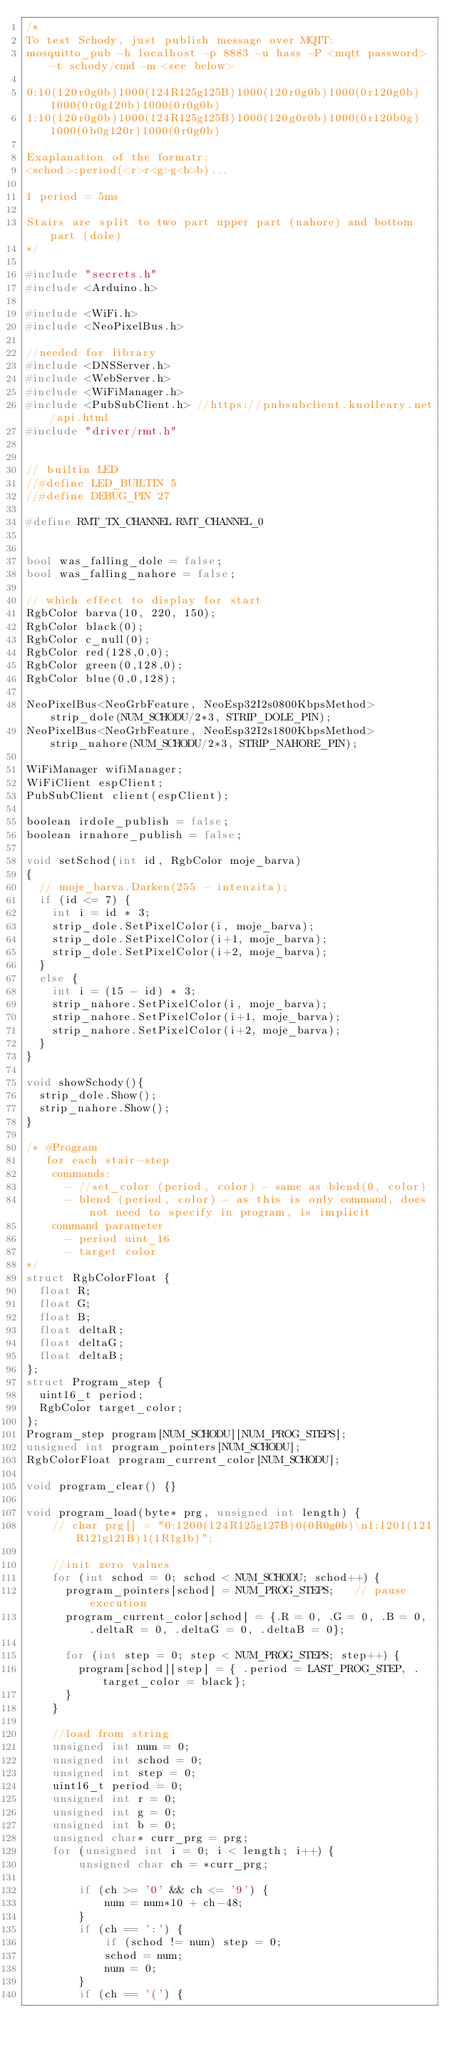<code> <loc_0><loc_0><loc_500><loc_500><_C++_>/*
To test Schody, just publish message over MQTT:
mosquitto_pub -h localhost -p 8883 -u hass -P <mqtt password> -t schody/cmd -m <see below>

0:10(120r0g0b)1000(124R125g125B)1000(120r0g0b)1000(0r120g0b)1000(0r0g120b)1000(0r0g0b)
1:10(120r0g0b)1000(124R125g125B)1000(120g0r0b)1000(0r120b0g)1000(0b0g120r)1000(0r0g0b)

Exaplanation of the formatr:
<schod>:period(<r>r<g>g<b>b)...

1 period = 5ms

Stairs are split to two part upper part (nahore) and bottom part (dole) 
*/

#include "secrets.h"
#include <Arduino.h>

#include <WiFi.h>
#include <NeoPixelBus.h>

//needed for library
#include <DNSServer.h>
#include <WebServer.h>
#include <WiFiManager.h>
#include <PubSubClient.h> //https://pubsubclient.knolleary.net/api.html
#include "driver/rmt.h"


// builtin LED
//#define LED_BUILTIN 5
//#define DEBUG_PIN 27

#define RMT_TX_CHANNEL RMT_CHANNEL_0


bool was_falling_dole = false;
bool was_falling_nahore = false;

// which effect to display for start
RgbColor barva(10, 220, 150);
RgbColor black(0);
RgbColor c_null(0);
RgbColor red(128,0,0);
RgbColor green(0,128,0);
RgbColor blue(0,0,128);

NeoPixelBus<NeoGrbFeature, NeoEsp32I2s0800KbpsMethod> strip_dole(NUM_SCHODU/2*3, STRIP_DOLE_PIN);
NeoPixelBus<NeoGrbFeature, NeoEsp32I2s1800KbpsMethod> strip_nahore(NUM_SCHODU/2*3, STRIP_NAHORE_PIN);

WiFiManager wifiManager;
WiFiClient espClient;
PubSubClient client(espClient);

boolean irdole_publish = false;
boolean irnahore_publish = false;

void setSchod(int id, RgbColor moje_barva)
{
  // moje_barva.Darken(255 - intenzita);
  if (id <= 7) {
    int i = id * 3;
    strip_dole.SetPixelColor(i, moje_barva);
    strip_dole.SetPixelColor(i+1, moje_barva);
    strip_dole.SetPixelColor(i+2, moje_barva);
  }
  else {
    int i = (15 - id) * 3;
    strip_nahore.SetPixelColor(i, moje_barva);
    strip_nahore.SetPixelColor(i+1, moje_barva);
    strip_nahore.SetPixelColor(i+2, moje_barva);
  }
}

void showSchody(){
  strip_dole.Show();
  strip_nahore.Show();
}

/* #Program
   for each stair-step
    commands:
      - //set_color (period, color) - same as blend(0, color)
      - blend (period, color) - as this is only command, does not need to specify in program, is implicit
    command parameter
      - period uint_16
      - target color
*/
struct RgbColorFloat {
  float R;
  float G;
  float B;
  float deltaR;
  float deltaG;
  float deltaB;
};
struct Program_step {
  uint16_t period;
  RgbColor target_color;
};
Program_step program[NUM_SCHODU][NUM_PROG_STEPS];
unsigned int program_pointers[NUM_SCHODU];
RgbColorFloat program_current_color[NUM_SCHODU];

void program_clear() {}

void program_load(byte* prg, unsigned int length) {
    // char prg[] = "0:1200(124R125g127B)0(0R0g0b)\n1:1201(121R121g121B)1(1R1g1b)";
    
    //init zero values
    for (int schod = 0; schod < NUM_SCHODU; schod++) {
      program_pointers[schod] = NUM_PROG_STEPS;   // pause execution
      program_current_color[schod] = {.R = 0, .G = 0, .B = 0, .deltaR = 0, .deltaG = 0, .deltaB = 0};

      for (int step = 0; step < NUM_PROG_STEPS; step++) {
        program[schod][step] = { .period = LAST_PROG_STEP, .target_color = black};
      }
    }

    //load from string
    unsigned int num = 0;
    unsigned int schod = 0;
    unsigned int step = 0;
    uint16_t period = 0;
    unsigned int r = 0;
    unsigned int g = 0;
    unsigned int b = 0;
    unsigned char* curr_prg = prg;
    for (unsigned int i = 0; i < length; i++) {
        unsigned char ch = *curr_prg;
        
        if (ch >= '0' && ch <= '9') {
            num = num*10 + ch-48;
        }
        if (ch == ':') {
            if (schod != num) step = 0;
            schod = num;
            num = 0;
        }
        if (ch == '(') {</code> 